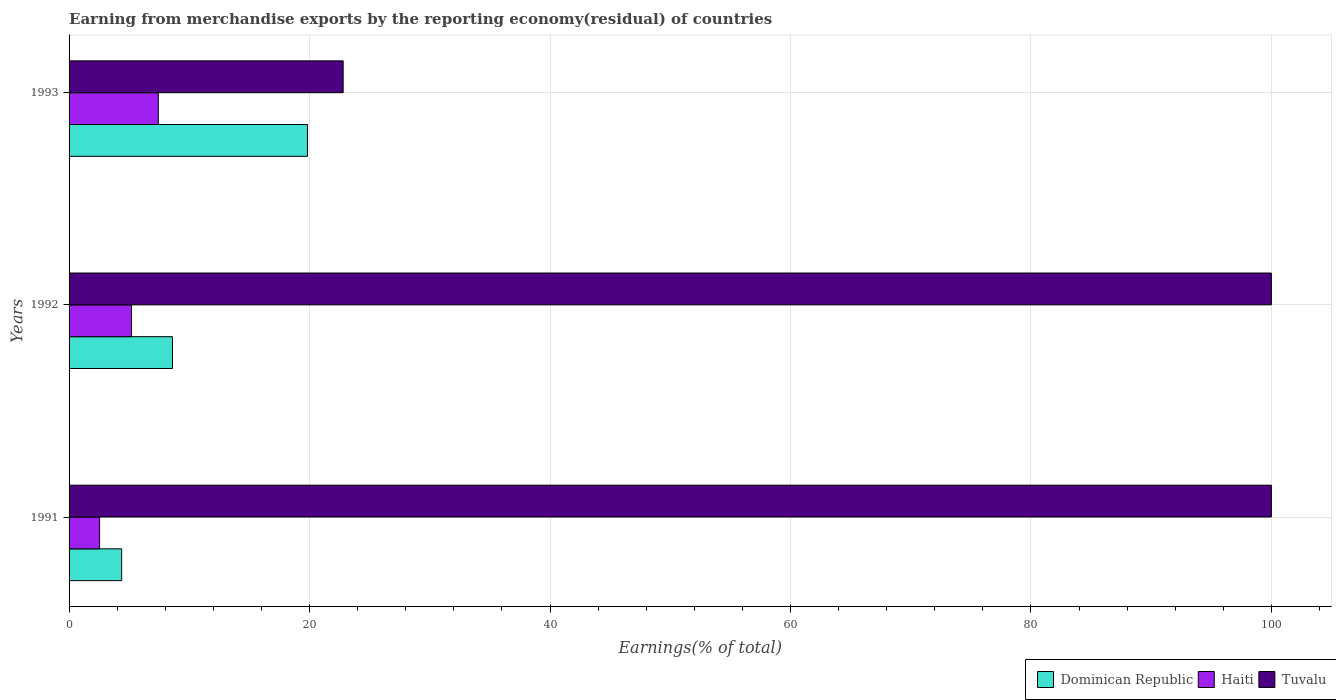What is the percentage of amount earned from merchandise exports in Dominican Republic in 1993?
Your answer should be very brief. 19.83. Across all years, what is the maximum percentage of amount earned from merchandise exports in Tuvalu?
Your answer should be very brief. 100. Across all years, what is the minimum percentage of amount earned from merchandise exports in Dominican Republic?
Provide a succinct answer. 4.37. In which year was the percentage of amount earned from merchandise exports in Dominican Republic maximum?
Offer a very short reply. 1993. In which year was the percentage of amount earned from merchandise exports in Haiti minimum?
Offer a very short reply. 1991. What is the total percentage of amount earned from merchandise exports in Tuvalu in the graph?
Make the answer very short. 222.8. What is the difference between the percentage of amount earned from merchandise exports in Haiti in 1992 and that in 1993?
Your response must be concise. -2.23. What is the difference between the percentage of amount earned from merchandise exports in Haiti in 1992 and the percentage of amount earned from merchandise exports in Tuvalu in 1991?
Your answer should be compact. -94.81. What is the average percentage of amount earned from merchandise exports in Haiti per year?
Your response must be concise. 5.05. In the year 1991, what is the difference between the percentage of amount earned from merchandise exports in Dominican Republic and percentage of amount earned from merchandise exports in Haiti?
Make the answer very short. 1.83. In how many years, is the percentage of amount earned from merchandise exports in Haiti greater than 84 %?
Your answer should be very brief. 0. What is the ratio of the percentage of amount earned from merchandise exports in Haiti in 1992 to that in 1993?
Make the answer very short. 0.7. Is the difference between the percentage of amount earned from merchandise exports in Dominican Republic in 1992 and 1993 greater than the difference between the percentage of amount earned from merchandise exports in Haiti in 1992 and 1993?
Your answer should be compact. No. What is the difference between the highest and the lowest percentage of amount earned from merchandise exports in Tuvalu?
Your answer should be very brief. 77.2. What does the 2nd bar from the top in 1991 represents?
Your answer should be very brief. Haiti. What does the 2nd bar from the bottom in 1993 represents?
Ensure brevity in your answer.  Haiti. Is it the case that in every year, the sum of the percentage of amount earned from merchandise exports in Tuvalu and percentage of amount earned from merchandise exports in Haiti is greater than the percentage of amount earned from merchandise exports in Dominican Republic?
Provide a succinct answer. Yes. Are all the bars in the graph horizontal?
Your response must be concise. Yes. What is the difference between two consecutive major ticks on the X-axis?
Keep it short and to the point. 20. Does the graph contain any zero values?
Your answer should be compact. No. Does the graph contain grids?
Keep it short and to the point. Yes. Where does the legend appear in the graph?
Give a very brief answer. Bottom right. How many legend labels are there?
Make the answer very short. 3. What is the title of the graph?
Make the answer very short. Earning from merchandise exports by the reporting economy(residual) of countries. What is the label or title of the X-axis?
Offer a very short reply. Earnings(% of total). What is the Earnings(% of total) of Dominican Republic in 1991?
Provide a short and direct response. 4.37. What is the Earnings(% of total) of Haiti in 1991?
Ensure brevity in your answer.  2.54. What is the Earnings(% of total) of Dominican Republic in 1992?
Make the answer very short. 8.6. What is the Earnings(% of total) in Haiti in 1992?
Your answer should be compact. 5.19. What is the Earnings(% of total) of Tuvalu in 1992?
Your answer should be compact. 100. What is the Earnings(% of total) in Dominican Republic in 1993?
Provide a succinct answer. 19.83. What is the Earnings(% of total) in Haiti in 1993?
Provide a short and direct response. 7.42. What is the Earnings(% of total) of Tuvalu in 1993?
Make the answer very short. 22.8. Across all years, what is the maximum Earnings(% of total) of Dominican Republic?
Give a very brief answer. 19.83. Across all years, what is the maximum Earnings(% of total) of Haiti?
Ensure brevity in your answer.  7.42. Across all years, what is the maximum Earnings(% of total) of Tuvalu?
Your answer should be very brief. 100. Across all years, what is the minimum Earnings(% of total) of Dominican Republic?
Ensure brevity in your answer.  4.37. Across all years, what is the minimum Earnings(% of total) of Haiti?
Keep it short and to the point. 2.54. Across all years, what is the minimum Earnings(% of total) of Tuvalu?
Your answer should be compact. 22.8. What is the total Earnings(% of total) in Dominican Republic in the graph?
Give a very brief answer. 32.8. What is the total Earnings(% of total) of Haiti in the graph?
Offer a very short reply. 15.15. What is the total Earnings(% of total) of Tuvalu in the graph?
Your answer should be compact. 222.8. What is the difference between the Earnings(% of total) in Dominican Republic in 1991 and that in 1992?
Provide a succinct answer. -4.23. What is the difference between the Earnings(% of total) of Haiti in 1991 and that in 1992?
Provide a succinct answer. -2.66. What is the difference between the Earnings(% of total) in Dominican Republic in 1991 and that in 1993?
Keep it short and to the point. -15.46. What is the difference between the Earnings(% of total) in Haiti in 1991 and that in 1993?
Make the answer very short. -4.88. What is the difference between the Earnings(% of total) of Tuvalu in 1991 and that in 1993?
Offer a terse response. 77.2. What is the difference between the Earnings(% of total) of Dominican Republic in 1992 and that in 1993?
Make the answer very short. -11.23. What is the difference between the Earnings(% of total) in Haiti in 1992 and that in 1993?
Make the answer very short. -2.23. What is the difference between the Earnings(% of total) of Tuvalu in 1992 and that in 1993?
Provide a succinct answer. 77.2. What is the difference between the Earnings(% of total) of Dominican Republic in 1991 and the Earnings(% of total) of Haiti in 1992?
Keep it short and to the point. -0.82. What is the difference between the Earnings(% of total) of Dominican Republic in 1991 and the Earnings(% of total) of Tuvalu in 1992?
Your response must be concise. -95.63. What is the difference between the Earnings(% of total) in Haiti in 1991 and the Earnings(% of total) in Tuvalu in 1992?
Your answer should be compact. -97.46. What is the difference between the Earnings(% of total) in Dominican Republic in 1991 and the Earnings(% of total) in Haiti in 1993?
Your response must be concise. -3.05. What is the difference between the Earnings(% of total) of Dominican Republic in 1991 and the Earnings(% of total) of Tuvalu in 1993?
Your answer should be compact. -18.42. What is the difference between the Earnings(% of total) in Haiti in 1991 and the Earnings(% of total) in Tuvalu in 1993?
Offer a very short reply. -20.26. What is the difference between the Earnings(% of total) in Dominican Republic in 1992 and the Earnings(% of total) in Haiti in 1993?
Your answer should be very brief. 1.18. What is the difference between the Earnings(% of total) in Dominican Republic in 1992 and the Earnings(% of total) in Tuvalu in 1993?
Offer a terse response. -14.2. What is the difference between the Earnings(% of total) of Haiti in 1992 and the Earnings(% of total) of Tuvalu in 1993?
Keep it short and to the point. -17.6. What is the average Earnings(% of total) of Dominican Republic per year?
Keep it short and to the point. 10.93. What is the average Earnings(% of total) of Haiti per year?
Provide a succinct answer. 5.05. What is the average Earnings(% of total) of Tuvalu per year?
Ensure brevity in your answer.  74.27. In the year 1991, what is the difference between the Earnings(% of total) of Dominican Republic and Earnings(% of total) of Haiti?
Give a very brief answer. 1.83. In the year 1991, what is the difference between the Earnings(% of total) in Dominican Republic and Earnings(% of total) in Tuvalu?
Your answer should be compact. -95.63. In the year 1991, what is the difference between the Earnings(% of total) in Haiti and Earnings(% of total) in Tuvalu?
Make the answer very short. -97.46. In the year 1992, what is the difference between the Earnings(% of total) of Dominican Republic and Earnings(% of total) of Haiti?
Keep it short and to the point. 3.4. In the year 1992, what is the difference between the Earnings(% of total) in Dominican Republic and Earnings(% of total) in Tuvalu?
Ensure brevity in your answer.  -91.4. In the year 1992, what is the difference between the Earnings(% of total) of Haiti and Earnings(% of total) of Tuvalu?
Ensure brevity in your answer.  -94.81. In the year 1993, what is the difference between the Earnings(% of total) in Dominican Republic and Earnings(% of total) in Haiti?
Your answer should be compact. 12.41. In the year 1993, what is the difference between the Earnings(% of total) in Dominican Republic and Earnings(% of total) in Tuvalu?
Your response must be concise. -2.97. In the year 1993, what is the difference between the Earnings(% of total) in Haiti and Earnings(% of total) in Tuvalu?
Offer a terse response. -15.37. What is the ratio of the Earnings(% of total) of Dominican Republic in 1991 to that in 1992?
Give a very brief answer. 0.51. What is the ratio of the Earnings(% of total) of Haiti in 1991 to that in 1992?
Ensure brevity in your answer.  0.49. What is the ratio of the Earnings(% of total) in Dominican Republic in 1991 to that in 1993?
Make the answer very short. 0.22. What is the ratio of the Earnings(% of total) in Haiti in 1991 to that in 1993?
Ensure brevity in your answer.  0.34. What is the ratio of the Earnings(% of total) in Tuvalu in 1991 to that in 1993?
Provide a short and direct response. 4.39. What is the ratio of the Earnings(% of total) of Dominican Republic in 1992 to that in 1993?
Offer a very short reply. 0.43. What is the ratio of the Earnings(% of total) in Haiti in 1992 to that in 1993?
Your answer should be compact. 0.7. What is the ratio of the Earnings(% of total) of Tuvalu in 1992 to that in 1993?
Offer a very short reply. 4.39. What is the difference between the highest and the second highest Earnings(% of total) in Dominican Republic?
Offer a very short reply. 11.23. What is the difference between the highest and the second highest Earnings(% of total) of Haiti?
Your answer should be very brief. 2.23. What is the difference between the highest and the lowest Earnings(% of total) of Dominican Republic?
Give a very brief answer. 15.46. What is the difference between the highest and the lowest Earnings(% of total) of Haiti?
Make the answer very short. 4.88. What is the difference between the highest and the lowest Earnings(% of total) in Tuvalu?
Provide a short and direct response. 77.2. 